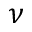<formula> <loc_0><loc_0><loc_500><loc_500>\nu</formula> 